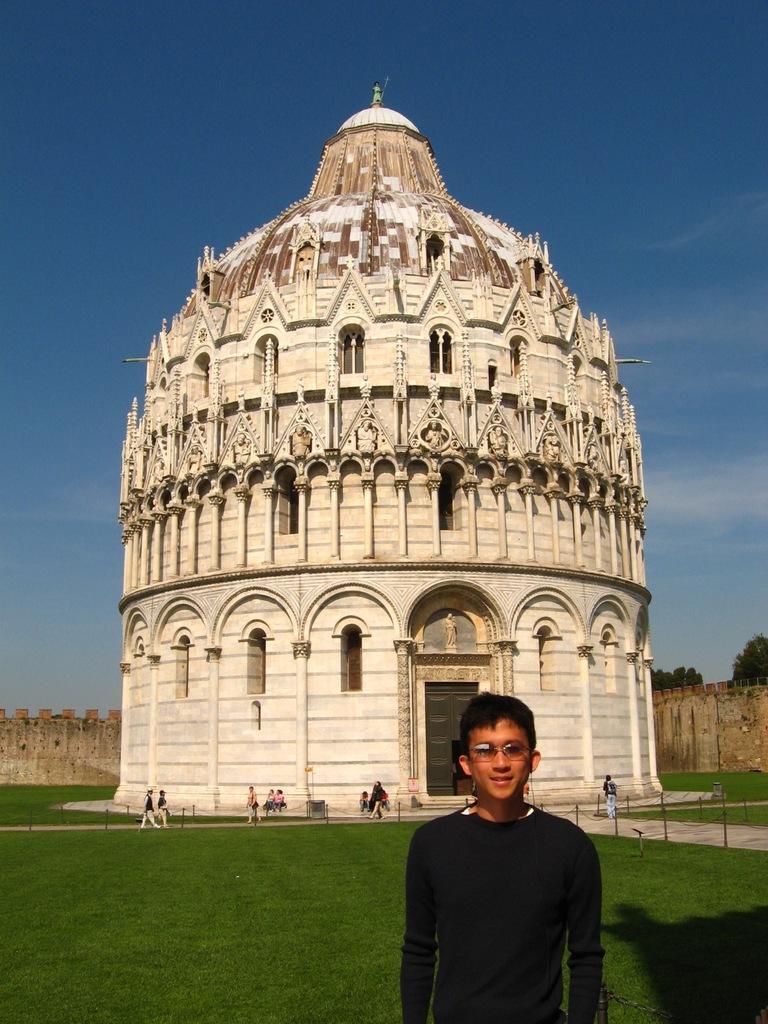Could you give a brief overview of what you see in this image? In the center of the image, we can see a building and in the background, there are people and we can see fences, trees and there is a wall. At the top, there is sky and at the bottom, there is ground. 